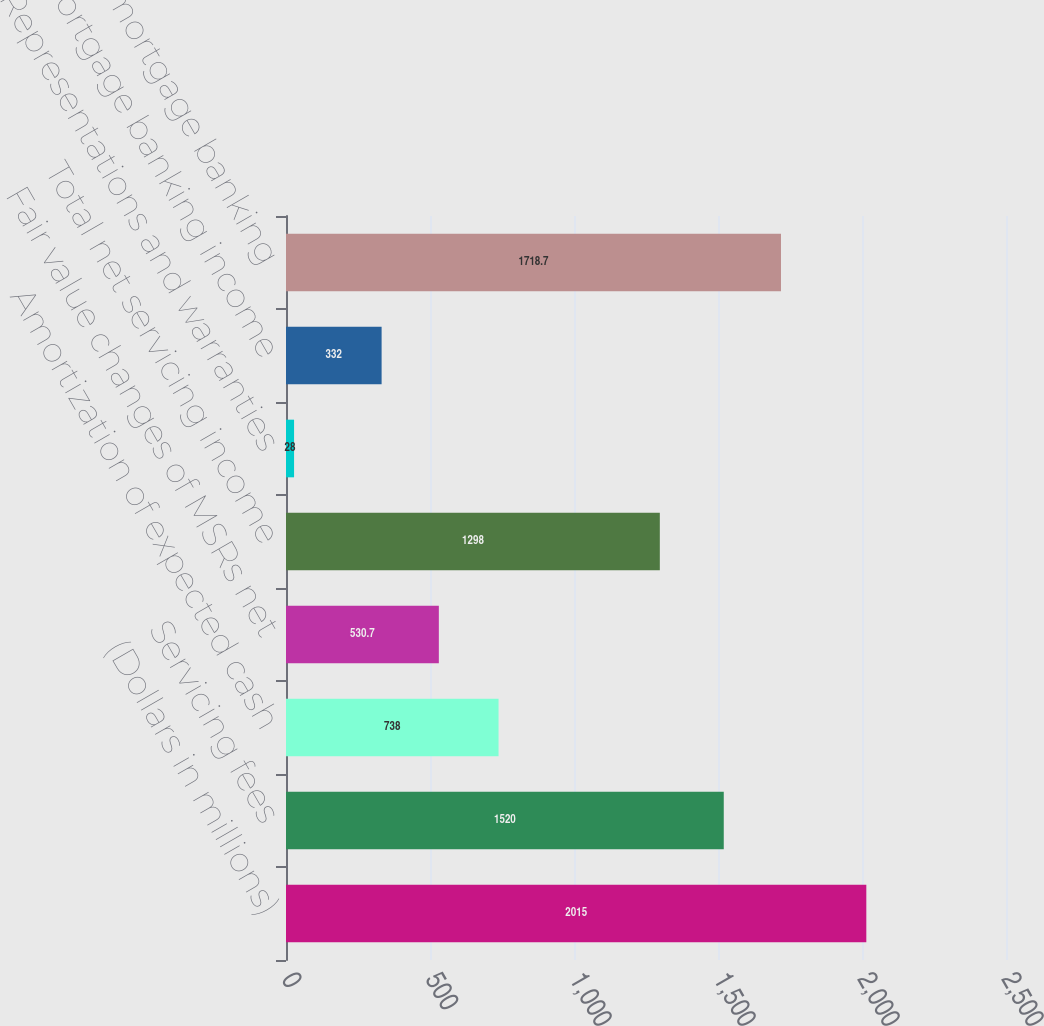Convert chart to OTSL. <chart><loc_0><loc_0><loc_500><loc_500><bar_chart><fcel>(Dollars in millions)<fcel>Servicing fees<fcel>Amortization of expected cash<fcel>Fair value changes of MSRs net<fcel>Total net servicing income<fcel>Representations and warranties<fcel>Other mortgage banking income<fcel>Total LAS mortgage banking<nl><fcel>2015<fcel>1520<fcel>738<fcel>530.7<fcel>1298<fcel>28<fcel>332<fcel>1718.7<nl></chart> 